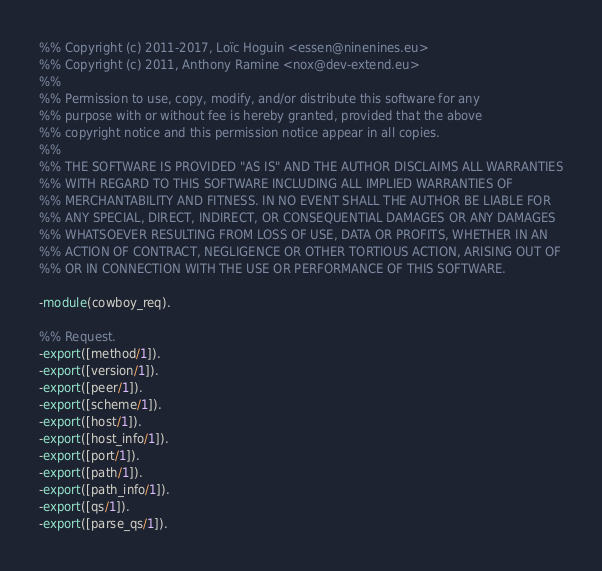<code> <loc_0><loc_0><loc_500><loc_500><_Erlang_>%% Copyright (c) 2011-2017, Loïc Hoguin <essen@ninenines.eu>
%% Copyright (c) 2011, Anthony Ramine <nox@dev-extend.eu>
%%
%% Permission to use, copy, modify, and/or distribute this software for any
%% purpose with or without fee is hereby granted, provided that the above
%% copyright notice and this permission notice appear in all copies.
%%
%% THE SOFTWARE IS PROVIDED "AS IS" AND THE AUTHOR DISCLAIMS ALL WARRANTIES
%% WITH REGARD TO THIS SOFTWARE INCLUDING ALL IMPLIED WARRANTIES OF
%% MERCHANTABILITY AND FITNESS. IN NO EVENT SHALL THE AUTHOR BE LIABLE FOR
%% ANY SPECIAL, DIRECT, INDIRECT, OR CONSEQUENTIAL DAMAGES OR ANY DAMAGES
%% WHATSOEVER RESULTING FROM LOSS OF USE, DATA OR PROFITS, WHETHER IN AN
%% ACTION OF CONTRACT, NEGLIGENCE OR OTHER TORTIOUS ACTION, ARISING OUT OF
%% OR IN CONNECTION WITH THE USE OR PERFORMANCE OF THIS SOFTWARE.

-module(cowboy_req).

%% Request.
-export([method/1]).
-export([version/1]).
-export([peer/1]).
-export([scheme/1]).
-export([host/1]).
-export([host_info/1]).
-export([port/1]).
-export([path/1]).
-export([path_info/1]).
-export([qs/1]).
-export([parse_qs/1]).</code> 